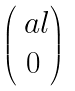Convert formula to latex. <formula><loc_0><loc_0><loc_500><loc_500>\begin{pmatrix} \ a l \\ 0 \end{pmatrix}</formula> 